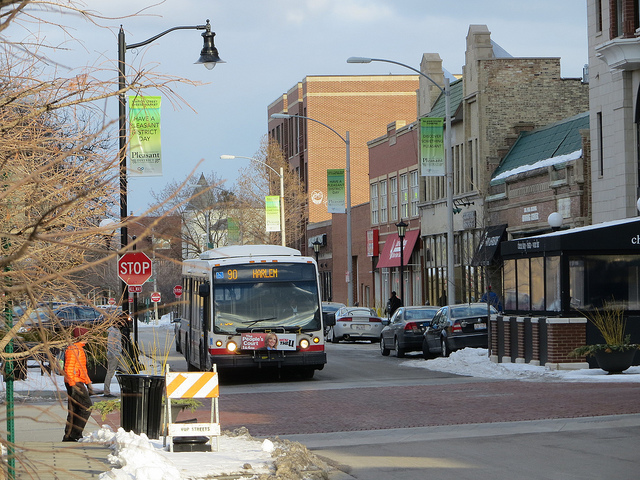Identify and read out the text in this image. STOP 